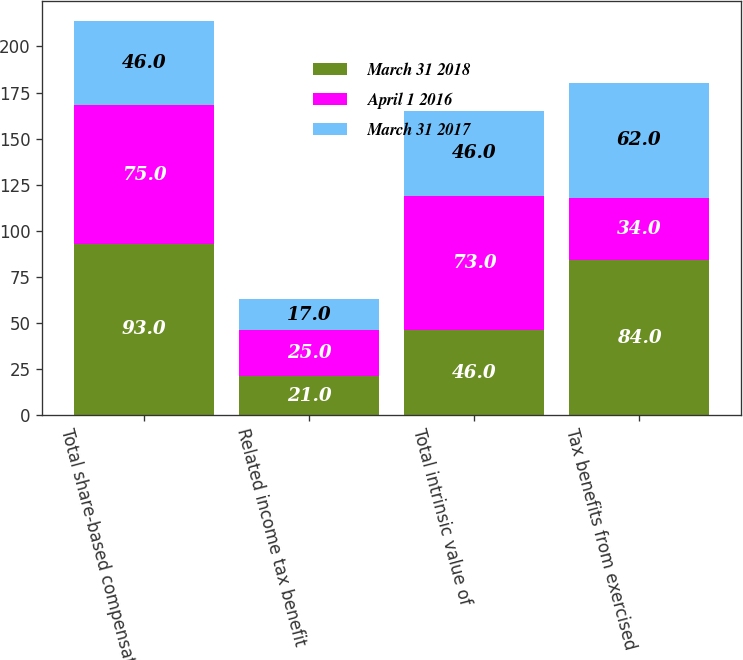Convert chart. <chart><loc_0><loc_0><loc_500><loc_500><stacked_bar_chart><ecel><fcel>Total share-based compensation<fcel>Related income tax benefit<fcel>Total intrinsic value of<fcel>Tax benefits from exercised<nl><fcel>March 31 2018<fcel>93<fcel>21<fcel>46<fcel>84<nl><fcel>April 1 2016<fcel>75<fcel>25<fcel>73<fcel>34<nl><fcel>March 31 2017<fcel>46<fcel>17<fcel>46<fcel>62<nl></chart> 